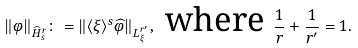Convert formula to latex. <formula><loc_0><loc_0><loc_500><loc_500>\| \varphi \| _ { \widehat { H } _ { s } ^ { r } } \colon = \| \langle \xi \rangle ^ { s } \widehat { \varphi } \| _ { L _ { \xi } ^ { r ^ { \prime } } } , \text { where } \frac { 1 } { r } + \frac { 1 } { r ^ { \prime } } = 1 .</formula> 